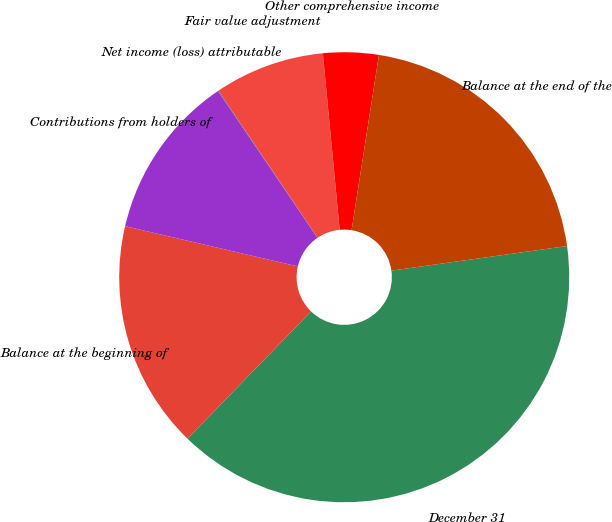<chart> <loc_0><loc_0><loc_500><loc_500><pie_chart><fcel>December 31<fcel>Balance at the beginning of<fcel>Contributions from holders of<fcel>Net income (loss) attributable<fcel>Fair value adjustment<fcel>Other comprehensive income<fcel>Balance at the end of the<nl><fcel>39.48%<fcel>16.38%<fcel>11.87%<fcel>0.04%<fcel>7.93%<fcel>3.98%<fcel>20.32%<nl></chart> 